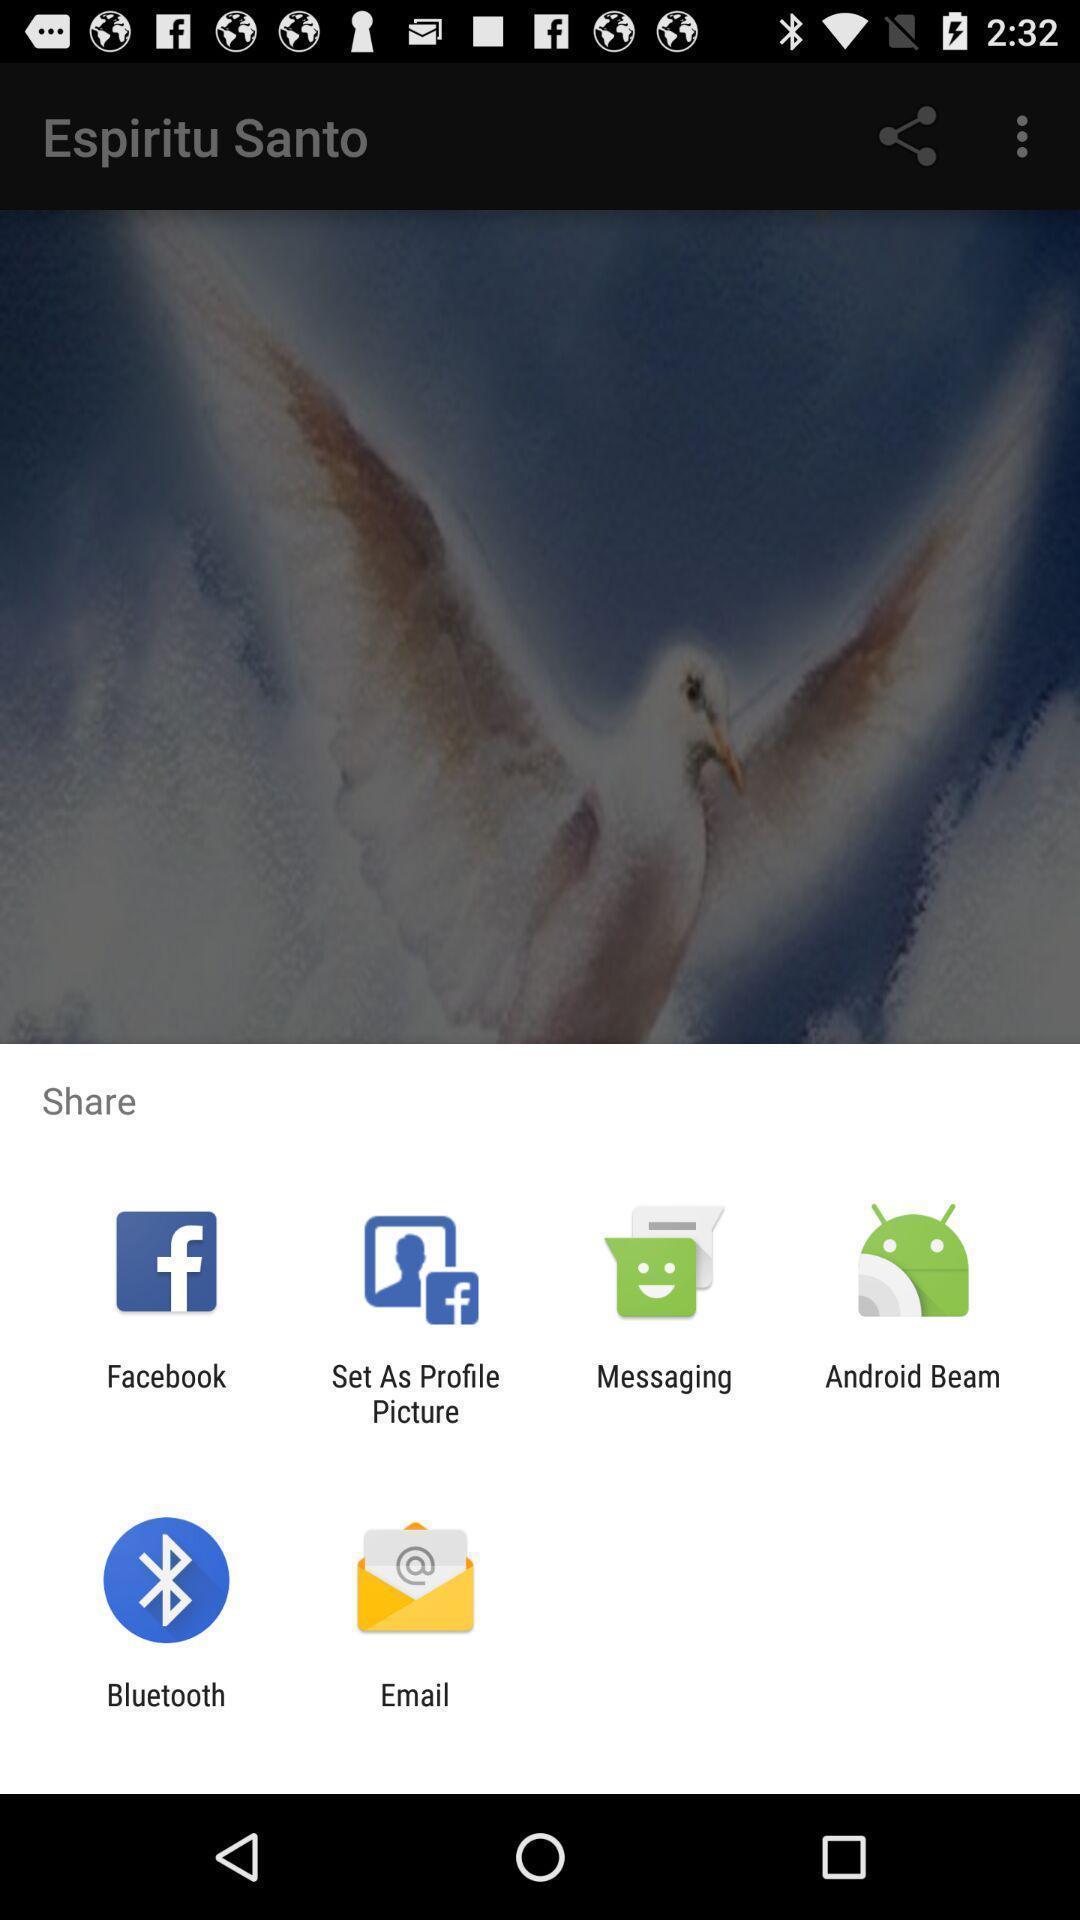Tell me about the visual elements in this screen capture. Pop-up shows share option with multiple applications. 